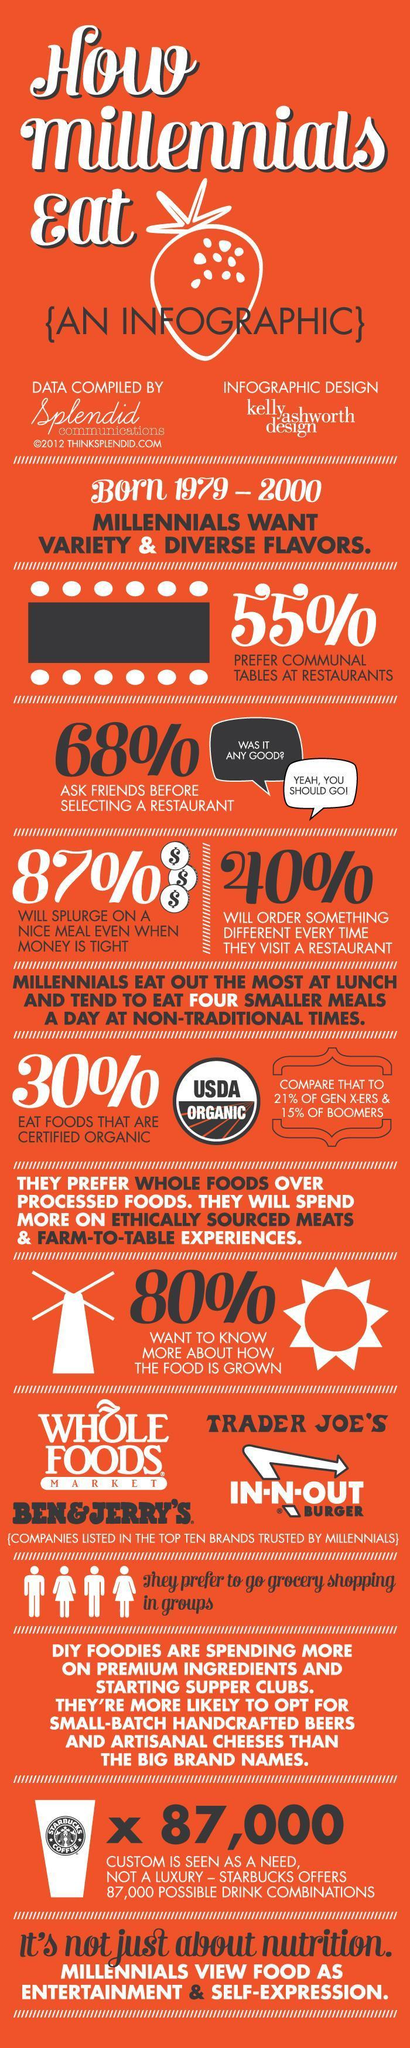which generation have lowest percentage of people who prefer organic food among them - millennials, boomers or generation X?
Answer the question with a short phrase. boomers which generation have higher percentage of people who prefer organic food among them - millennials, boomers or generation X? millenials 